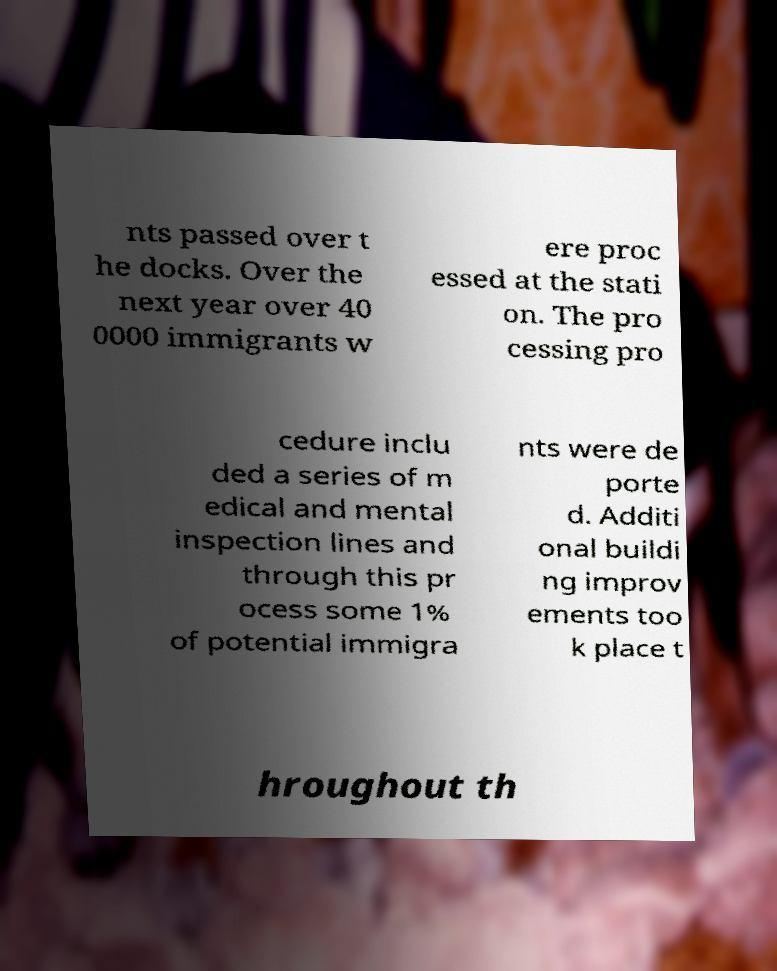Can you read and provide the text displayed in the image?This photo seems to have some interesting text. Can you extract and type it out for me? nts passed over t he docks. Over the next year over 40 0000 immigrants w ere proc essed at the stati on. The pro cessing pro cedure inclu ded a series of m edical and mental inspection lines and through this pr ocess some 1% of potential immigra nts were de porte d. Additi onal buildi ng improv ements too k place t hroughout th 